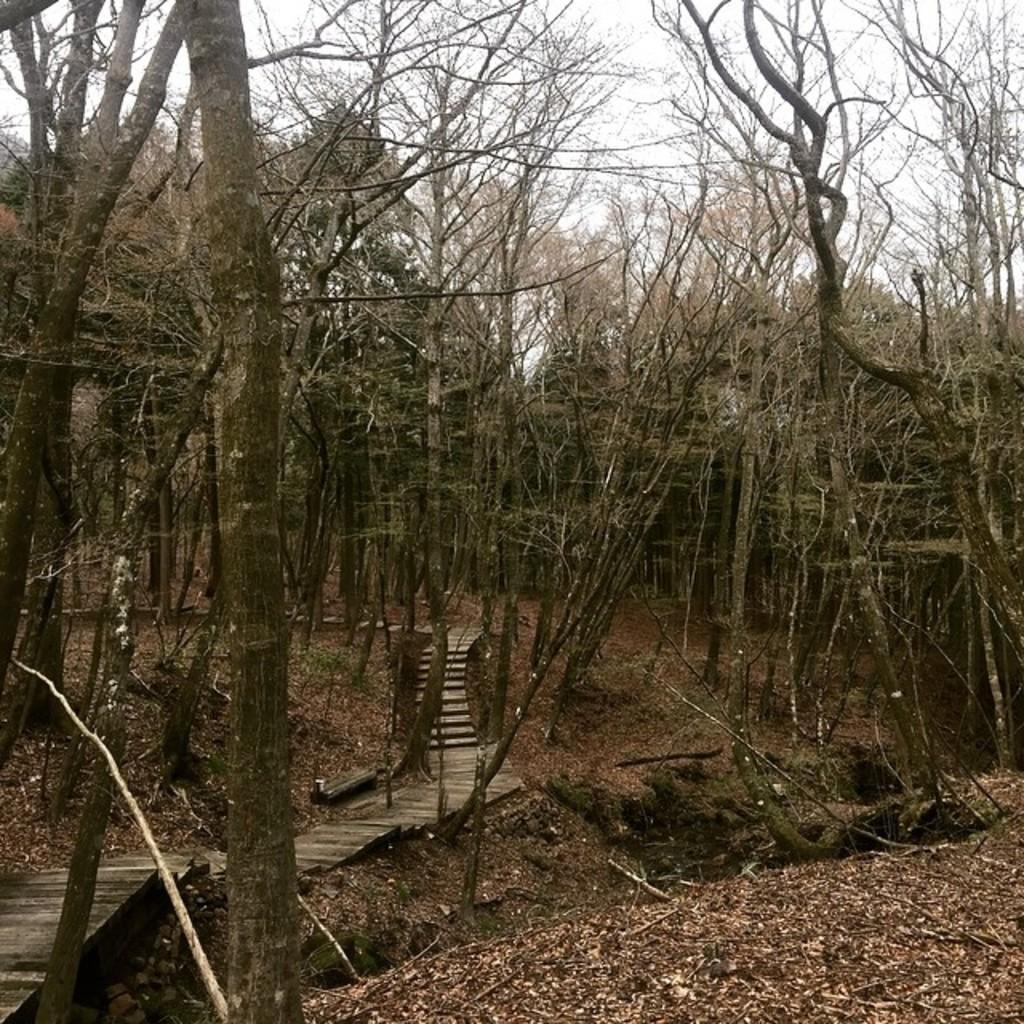In one or two sentences, can you explain what this image depicts? In this image we can see a sky. There are many trees in the image. There are many leaves in the image. There is a walkway in the image. 